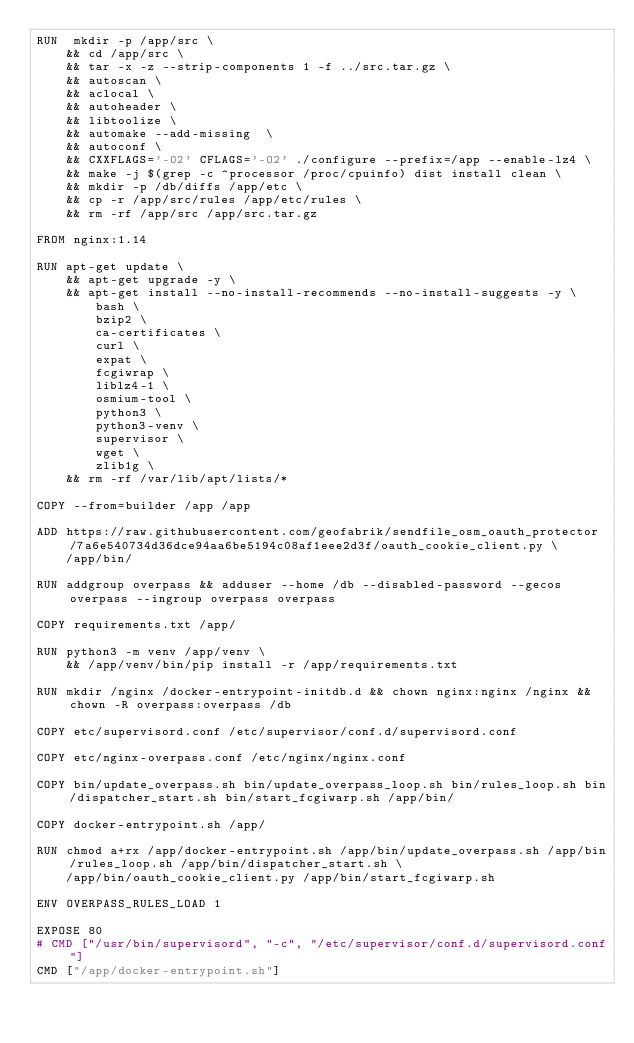<code> <loc_0><loc_0><loc_500><loc_500><_Dockerfile_>RUN  mkdir -p /app/src \
    && cd /app/src \
    && tar -x -z --strip-components 1 -f ../src.tar.gz \
    && autoscan \
    && aclocal \
    && autoheader \
    && libtoolize \
    && automake --add-missing  \
    && autoconf \
    && CXXFLAGS='-O2' CFLAGS='-O2' ./configure --prefix=/app --enable-lz4 \
    && make -j $(grep -c ^processor /proc/cpuinfo) dist install clean \
    && mkdir -p /db/diffs /app/etc \
    && cp -r /app/src/rules /app/etc/rules \
    && rm -rf /app/src /app/src.tar.gz

FROM nginx:1.14

RUN apt-get update \
    && apt-get upgrade -y \
    && apt-get install --no-install-recommends --no-install-suggests -y \
        bash \
        bzip2 \
        ca-certificates \
        curl \
        expat \
        fcgiwrap \
        liblz4-1 \
        osmium-tool \
        python3 \
        python3-venv \
        supervisor \
        wget \
        zlib1g \
    && rm -rf /var/lib/apt/lists/*

COPY --from=builder /app /app

ADD https://raw.githubusercontent.com/geofabrik/sendfile_osm_oauth_protector/7a6e540734d36dce94aa6be5194c08af1eee2d3f/oauth_cookie_client.py \
    /app/bin/

RUN addgroup overpass && adduser --home /db --disabled-password --gecos overpass --ingroup overpass overpass

COPY requirements.txt /app/

RUN python3 -m venv /app/venv \
    && /app/venv/bin/pip install -r /app/requirements.txt

RUN mkdir /nginx /docker-entrypoint-initdb.d && chown nginx:nginx /nginx && chown -R overpass:overpass /db

COPY etc/supervisord.conf /etc/supervisor/conf.d/supervisord.conf

COPY etc/nginx-overpass.conf /etc/nginx/nginx.conf

COPY bin/update_overpass.sh bin/update_overpass_loop.sh bin/rules_loop.sh bin/dispatcher_start.sh bin/start_fcgiwarp.sh /app/bin/

COPY docker-entrypoint.sh /app/

RUN chmod a+rx /app/docker-entrypoint.sh /app/bin/update_overpass.sh /app/bin/rules_loop.sh /app/bin/dispatcher_start.sh \
    /app/bin/oauth_cookie_client.py /app/bin/start_fcgiwarp.sh

ENV OVERPASS_RULES_LOAD 1

EXPOSE 80
# CMD ["/usr/bin/supervisord", "-c", "/etc/supervisor/conf.d/supervisord.conf"]
CMD ["/app/docker-entrypoint.sh"]
</code> 